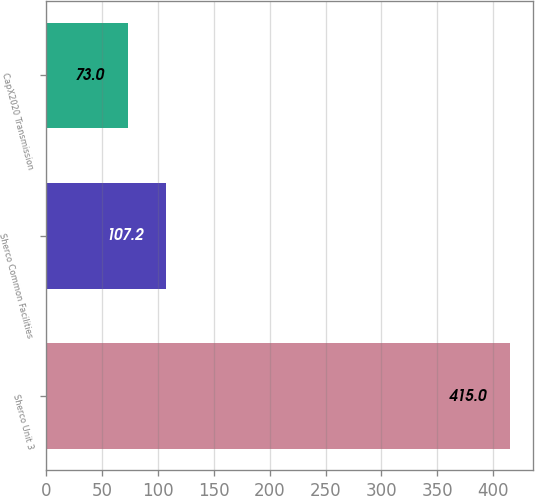<chart> <loc_0><loc_0><loc_500><loc_500><bar_chart><fcel>Sherco Unit 3<fcel>Sherco Common Facilities<fcel>CapX2020 Transmission<nl><fcel>415<fcel>107.2<fcel>73<nl></chart> 